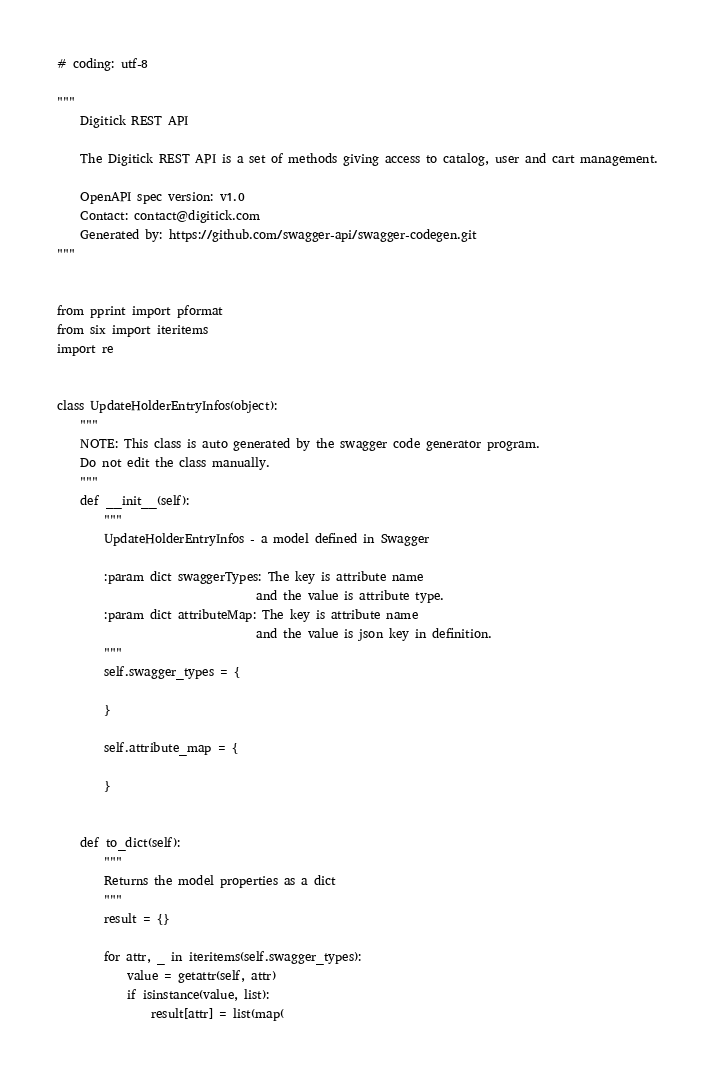<code> <loc_0><loc_0><loc_500><loc_500><_Python_># coding: utf-8

"""
    Digitick REST API

    The Digitick REST API is a set of methods giving access to catalog, user and cart management.

    OpenAPI spec version: v1.0
    Contact: contact@digitick.com
    Generated by: https://github.com/swagger-api/swagger-codegen.git
"""


from pprint import pformat
from six import iteritems
import re


class UpdateHolderEntryInfos(object):
    """
    NOTE: This class is auto generated by the swagger code generator program.
    Do not edit the class manually.
    """
    def __init__(self):
        """
        UpdateHolderEntryInfos - a model defined in Swagger

        :param dict swaggerTypes: The key is attribute name
                                  and the value is attribute type.
        :param dict attributeMap: The key is attribute name
                                  and the value is json key in definition.
        """
        self.swagger_types = {
            
        }

        self.attribute_map = {
            
        }


    def to_dict(self):
        """
        Returns the model properties as a dict
        """
        result = {}

        for attr, _ in iteritems(self.swagger_types):
            value = getattr(self, attr)
            if isinstance(value, list):
                result[attr] = list(map(</code> 